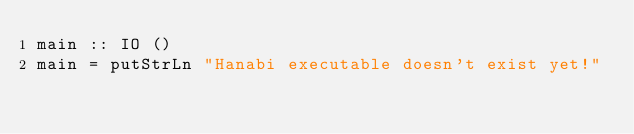<code> <loc_0><loc_0><loc_500><loc_500><_Haskell_>main :: IO ()
main = putStrLn "Hanabi executable doesn't exist yet!"
</code> 